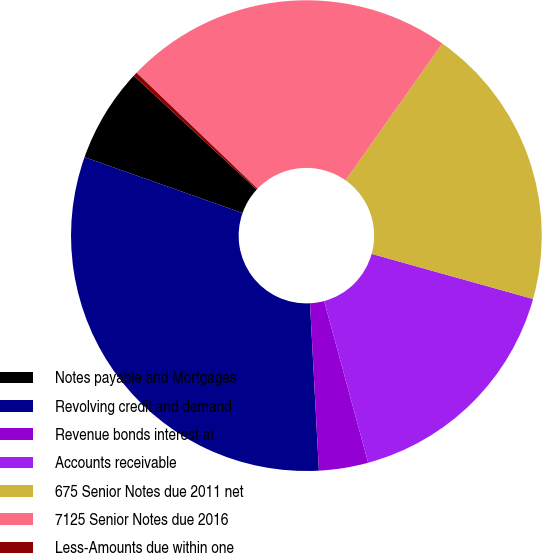Convert chart. <chart><loc_0><loc_0><loc_500><loc_500><pie_chart><fcel>Notes payable and Mortgages<fcel>Revolving credit and demand<fcel>Revenue bonds interest at<fcel>Accounts receivable<fcel>675 Senior Notes due 2011 net<fcel>7125 Senior Notes due 2016<fcel>Less-Amounts due within one<nl><fcel>6.48%<fcel>31.26%<fcel>3.38%<fcel>16.44%<fcel>19.54%<fcel>22.63%<fcel>0.28%<nl></chart> 